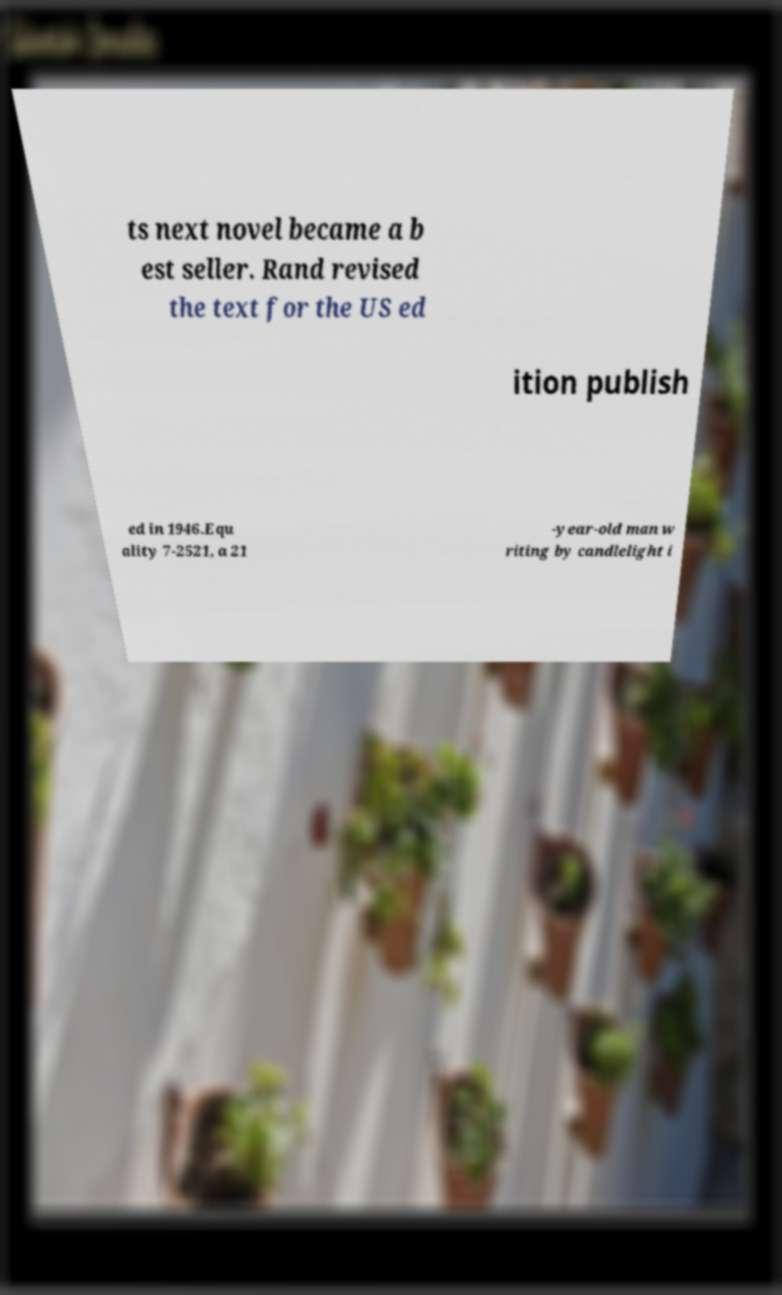Could you extract and type out the text from this image? ts next novel became a b est seller. Rand revised the text for the US ed ition publish ed in 1946.Equ ality 7-2521, a 21 -year-old man w riting by candlelight i 